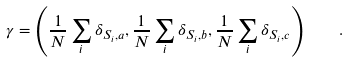<formula> <loc_0><loc_0><loc_500><loc_500>\gamma = \left ( \frac { 1 } { N } \sum _ { i } \delta _ { S _ { i } , a } , \frac { 1 } { N } \sum _ { i } \delta _ { S _ { i } , b } , \frac { 1 } { N } \sum _ { i } \delta _ { S _ { i } , c } \right ) \quad .</formula> 